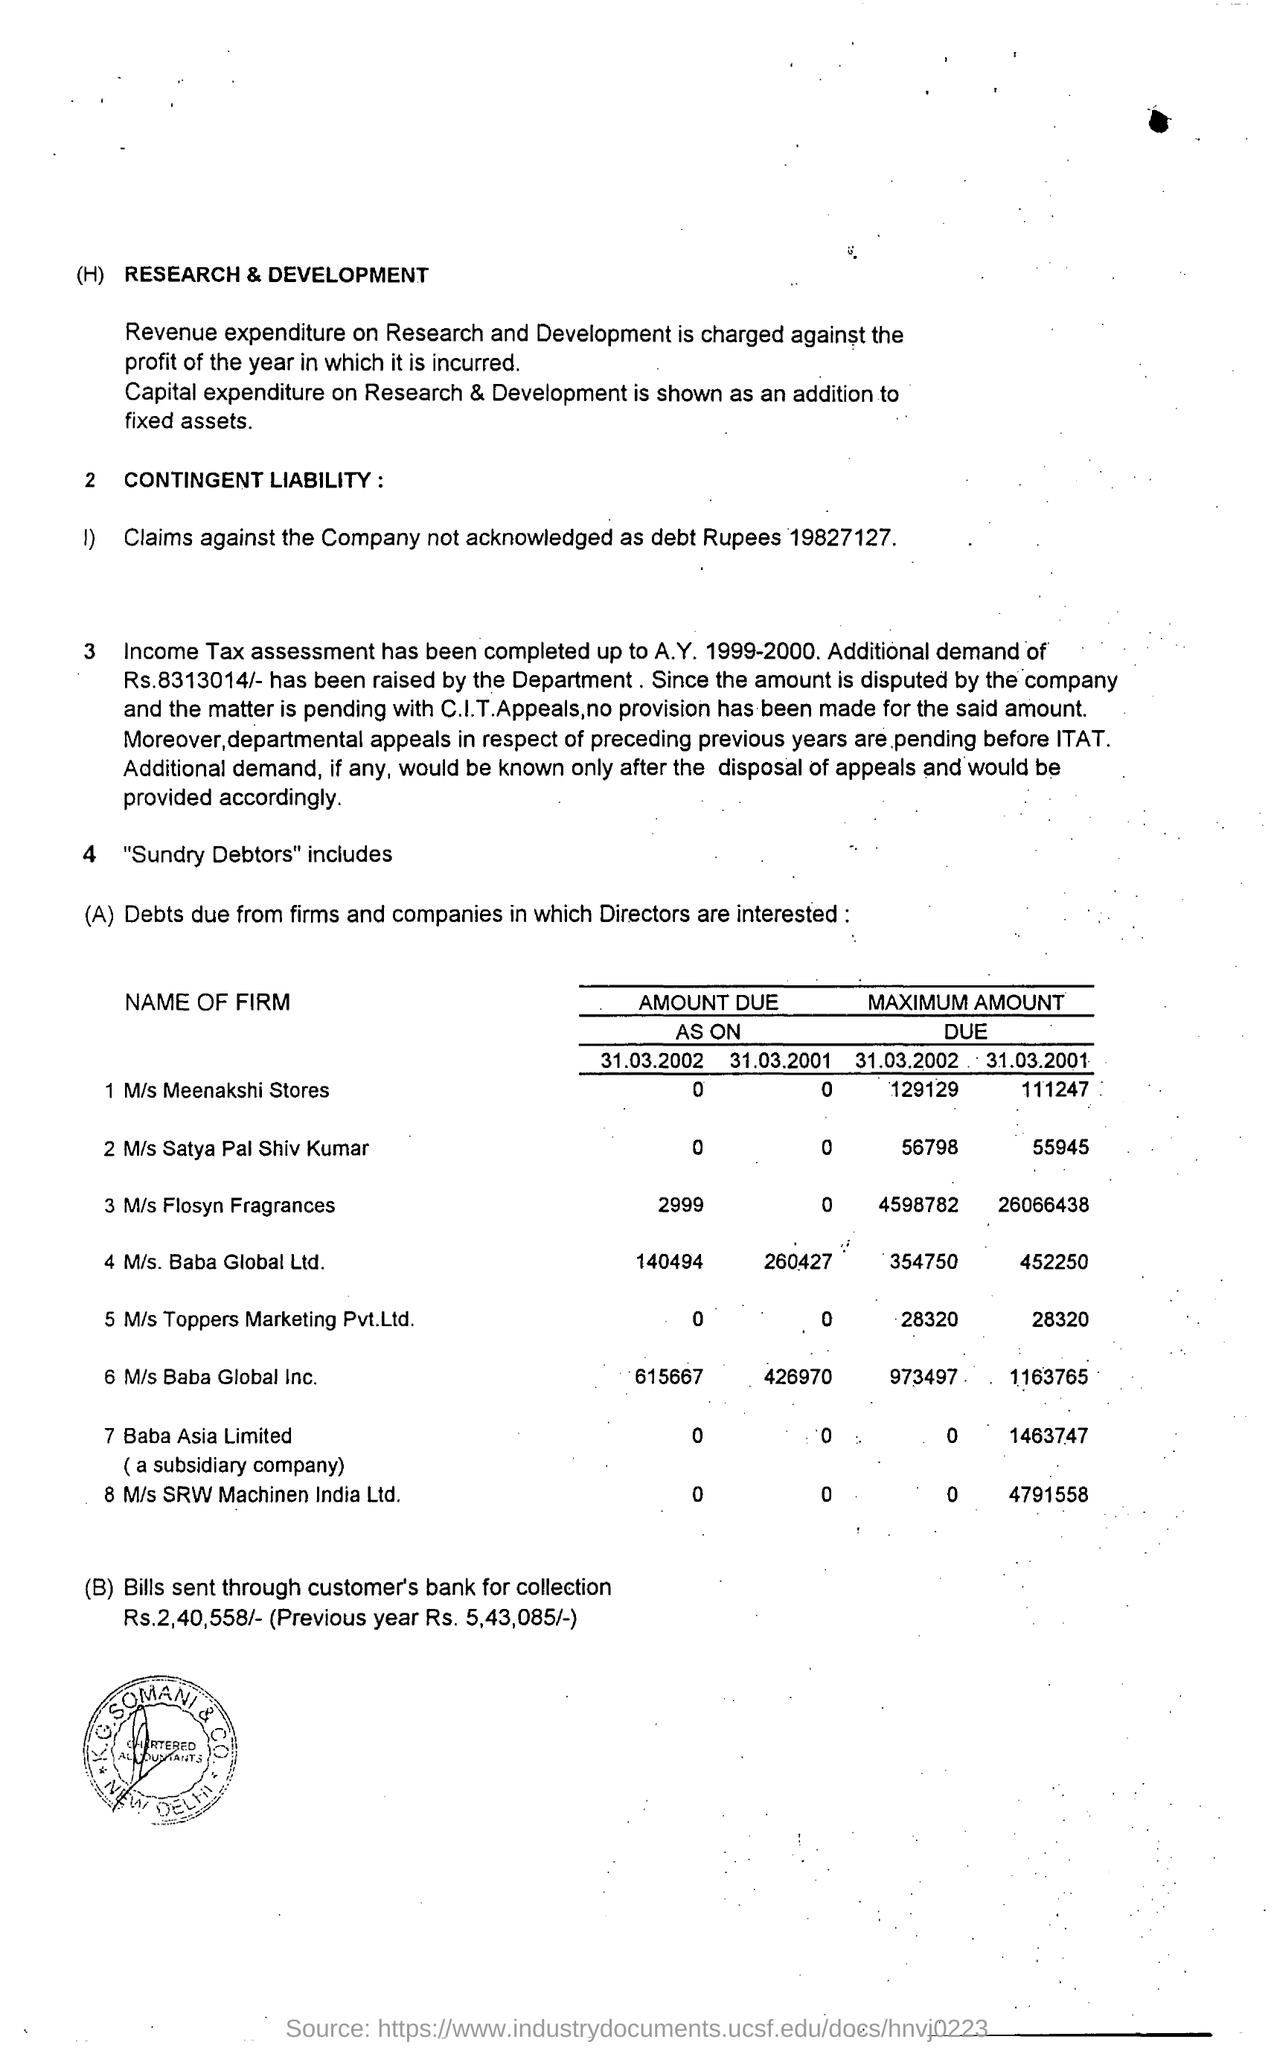"Income Tax assessment has been completed upto" which A.Y.?
Make the answer very short. Income Tax assessment has been completed up to A.Y. 1999-2000. What is the first "NAME OF FIRM" mentioned?
Provide a succinct answer. M/s Meenakshi Stores. What is the "MAXIMUM AMOUNT DUE" for M/s Meenakshi Stores as on 31.03.2002?
Offer a terse response. 129129. What is the "MAXIMUM AMOUNT DUE" for M/s Baba Global Ltd  as on 31.03.2001?
Offer a very short reply. 452250. What is the  AMOUNT DUE AS ON 31.03.2002 for M/s Baba Global Ltd firm?
Your answer should be very brief. 140494. What is the AMOUNT DUE AS ON 31.03.2001 for M/s Baba Global Ltd firm?
Give a very brief answer. 260427. 